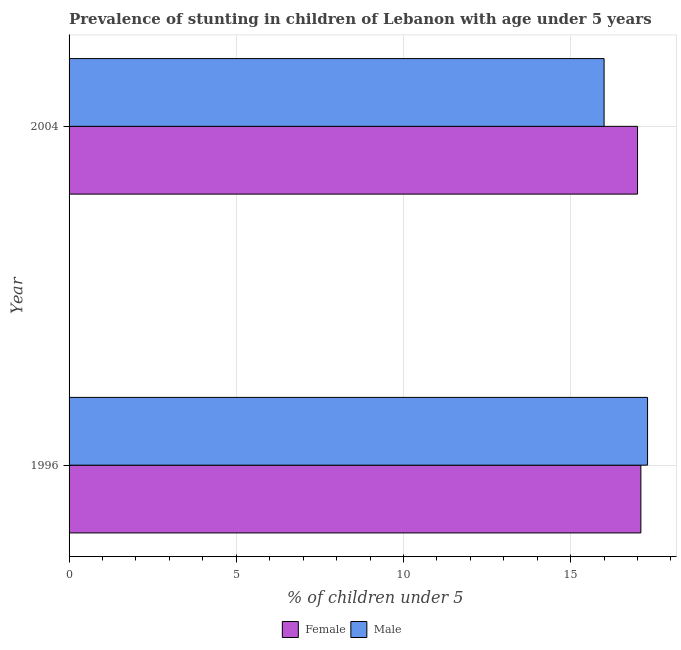How many different coloured bars are there?
Your answer should be compact. 2. How many bars are there on the 2nd tick from the bottom?
Provide a short and direct response. 2. What is the label of the 2nd group of bars from the top?
Provide a succinct answer. 1996. In how many cases, is the number of bars for a given year not equal to the number of legend labels?
Your answer should be compact. 0. What is the percentage of stunted male children in 1996?
Your answer should be very brief. 17.3. Across all years, what is the maximum percentage of stunted male children?
Provide a succinct answer. 17.3. What is the total percentage of stunted female children in the graph?
Offer a terse response. 34.1. What is the difference between the percentage of stunted female children in 1996 and the percentage of stunted male children in 2004?
Provide a succinct answer. 1.1. What is the average percentage of stunted male children per year?
Make the answer very short. 16.65. What is the ratio of the percentage of stunted male children in 1996 to that in 2004?
Ensure brevity in your answer.  1.08. Is the percentage of stunted male children in 1996 less than that in 2004?
Offer a terse response. No. Is the difference between the percentage of stunted male children in 1996 and 2004 greater than the difference between the percentage of stunted female children in 1996 and 2004?
Provide a short and direct response. Yes. What does the 1st bar from the top in 1996 represents?
Provide a short and direct response. Male. What does the 2nd bar from the bottom in 1996 represents?
Offer a very short reply. Male. Are the values on the major ticks of X-axis written in scientific E-notation?
Ensure brevity in your answer.  No. Does the graph contain any zero values?
Your answer should be compact. No. Does the graph contain grids?
Provide a short and direct response. Yes. Where does the legend appear in the graph?
Keep it short and to the point. Bottom center. How many legend labels are there?
Offer a terse response. 2. How are the legend labels stacked?
Provide a short and direct response. Horizontal. What is the title of the graph?
Provide a short and direct response. Prevalence of stunting in children of Lebanon with age under 5 years. What is the label or title of the X-axis?
Ensure brevity in your answer.   % of children under 5. What is the  % of children under 5 in Female in 1996?
Give a very brief answer. 17.1. What is the  % of children under 5 of Male in 1996?
Make the answer very short. 17.3. What is the  % of children under 5 of Male in 2004?
Offer a very short reply. 16. Across all years, what is the maximum  % of children under 5 in Female?
Offer a very short reply. 17.1. Across all years, what is the maximum  % of children under 5 of Male?
Offer a very short reply. 17.3. Across all years, what is the minimum  % of children under 5 in Female?
Provide a short and direct response. 17. Across all years, what is the minimum  % of children under 5 in Male?
Your answer should be compact. 16. What is the total  % of children under 5 in Female in the graph?
Make the answer very short. 34.1. What is the total  % of children under 5 of Male in the graph?
Offer a terse response. 33.3. What is the average  % of children under 5 of Female per year?
Offer a very short reply. 17.05. What is the average  % of children under 5 of Male per year?
Your response must be concise. 16.65. What is the ratio of the  % of children under 5 of Female in 1996 to that in 2004?
Make the answer very short. 1.01. What is the ratio of the  % of children under 5 of Male in 1996 to that in 2004?
Provide a succinct answer. 1.08. What is the difference between the highest and the second highest  % of children under 5 in Female?
Keep it short and to the point. 0.1. What is the difference between the highest and the lowest  % of children under 5 of Female?
Provide a succinct answer. 0.1. 